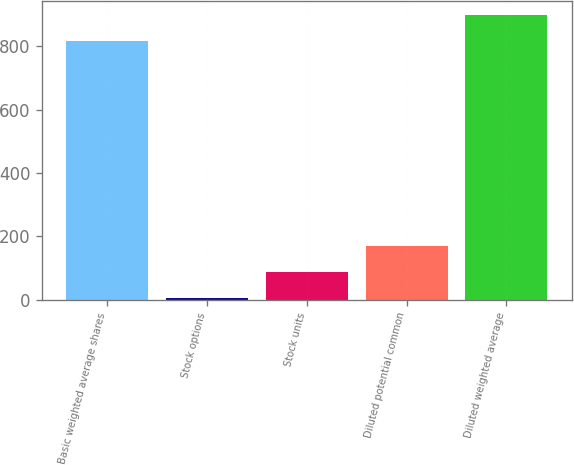Convert chart. <chart><loc_0><loc_0><loc_500><loc_500><bar_chart><fcel>Basic weighted average shares<fcel>Stock options<fcel>Stock units<fcel>Diluted potential common<fcel>Diluted weighted average<nl><fcel>816.2<fcel>5.1<fcel>87.52<fcel>169.94<fcel>898.62<nl></chart> 